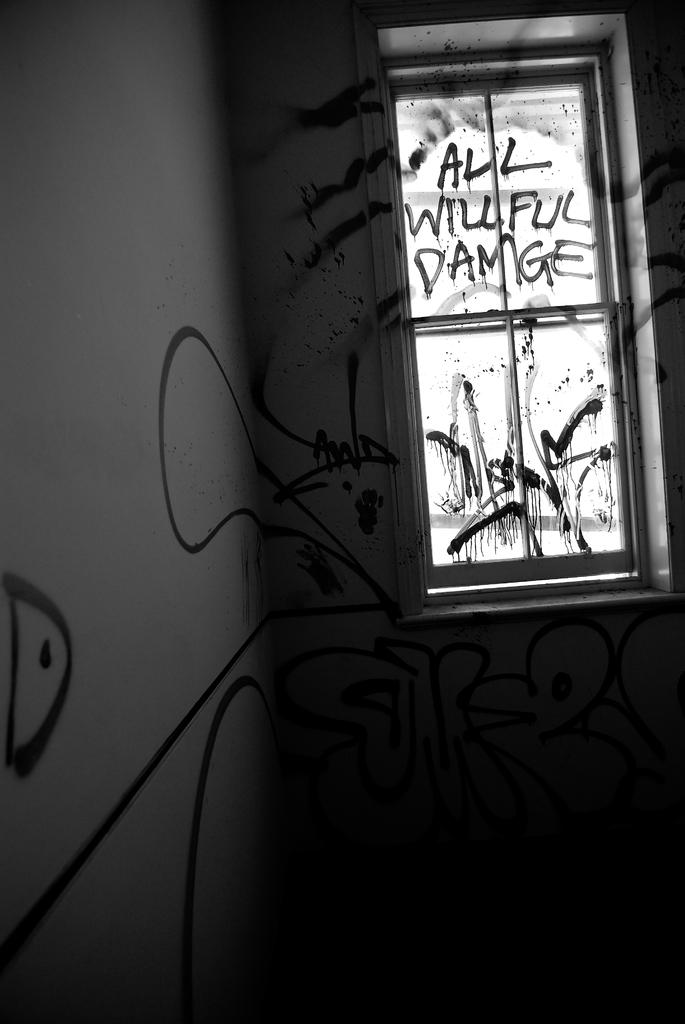What type of space is depicted in the image? The image shows a room. What can be seen on the walls of the room? There is graffiti and text on the walls of the room. Can you describe the window in the room? There is a window in the room. What is written on the glass of the window? There is text on the glass of the window. How many cups are visible on the walls of the room? There are no cups visible on the walls of the room. Are there any spiders crawling on the text in the image? There are no spiders present in the image. 